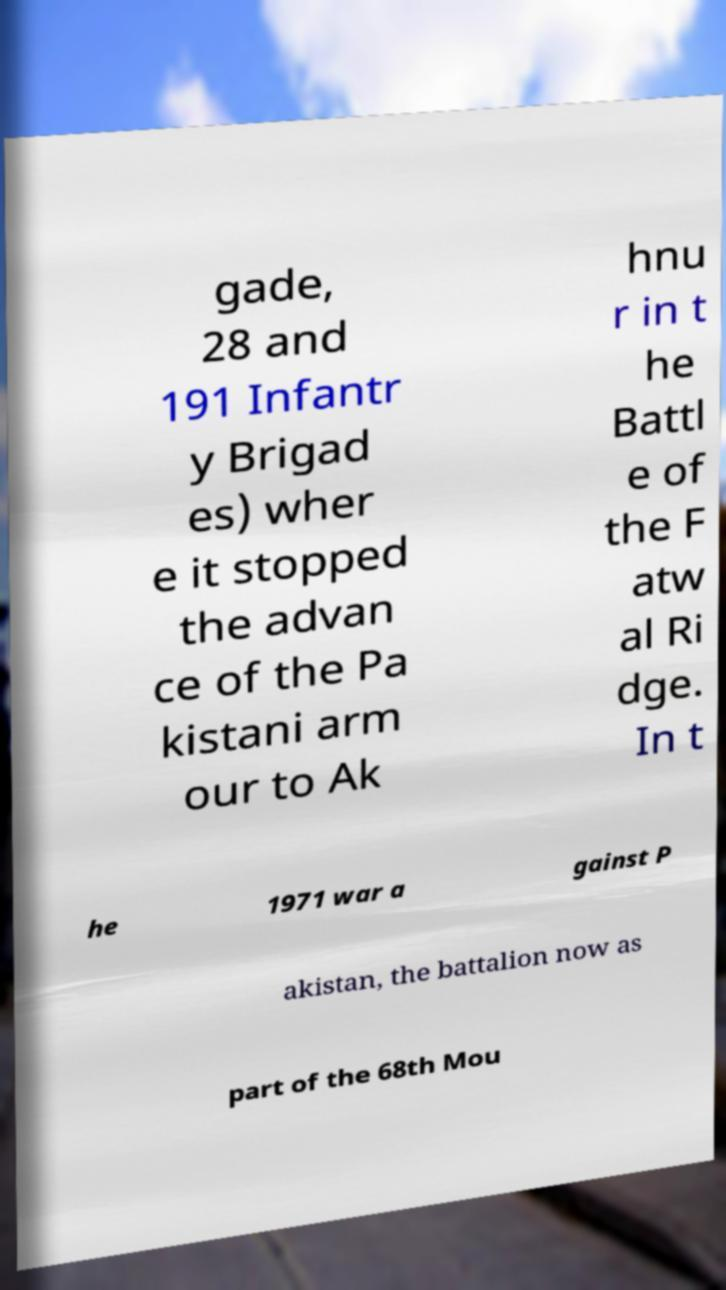Could you assist in decoding the text presented in this image and type it out clearly? gade, 28 and 191 Infantr y Brigad es) wher e it stopped the advan ce of the Pa kistani arm our to Ak hnu r in t he Battl e of the F atw al Ri dge. In t he 1971 war a gainst P akistan, the battalion now as part of the 68th Mou 